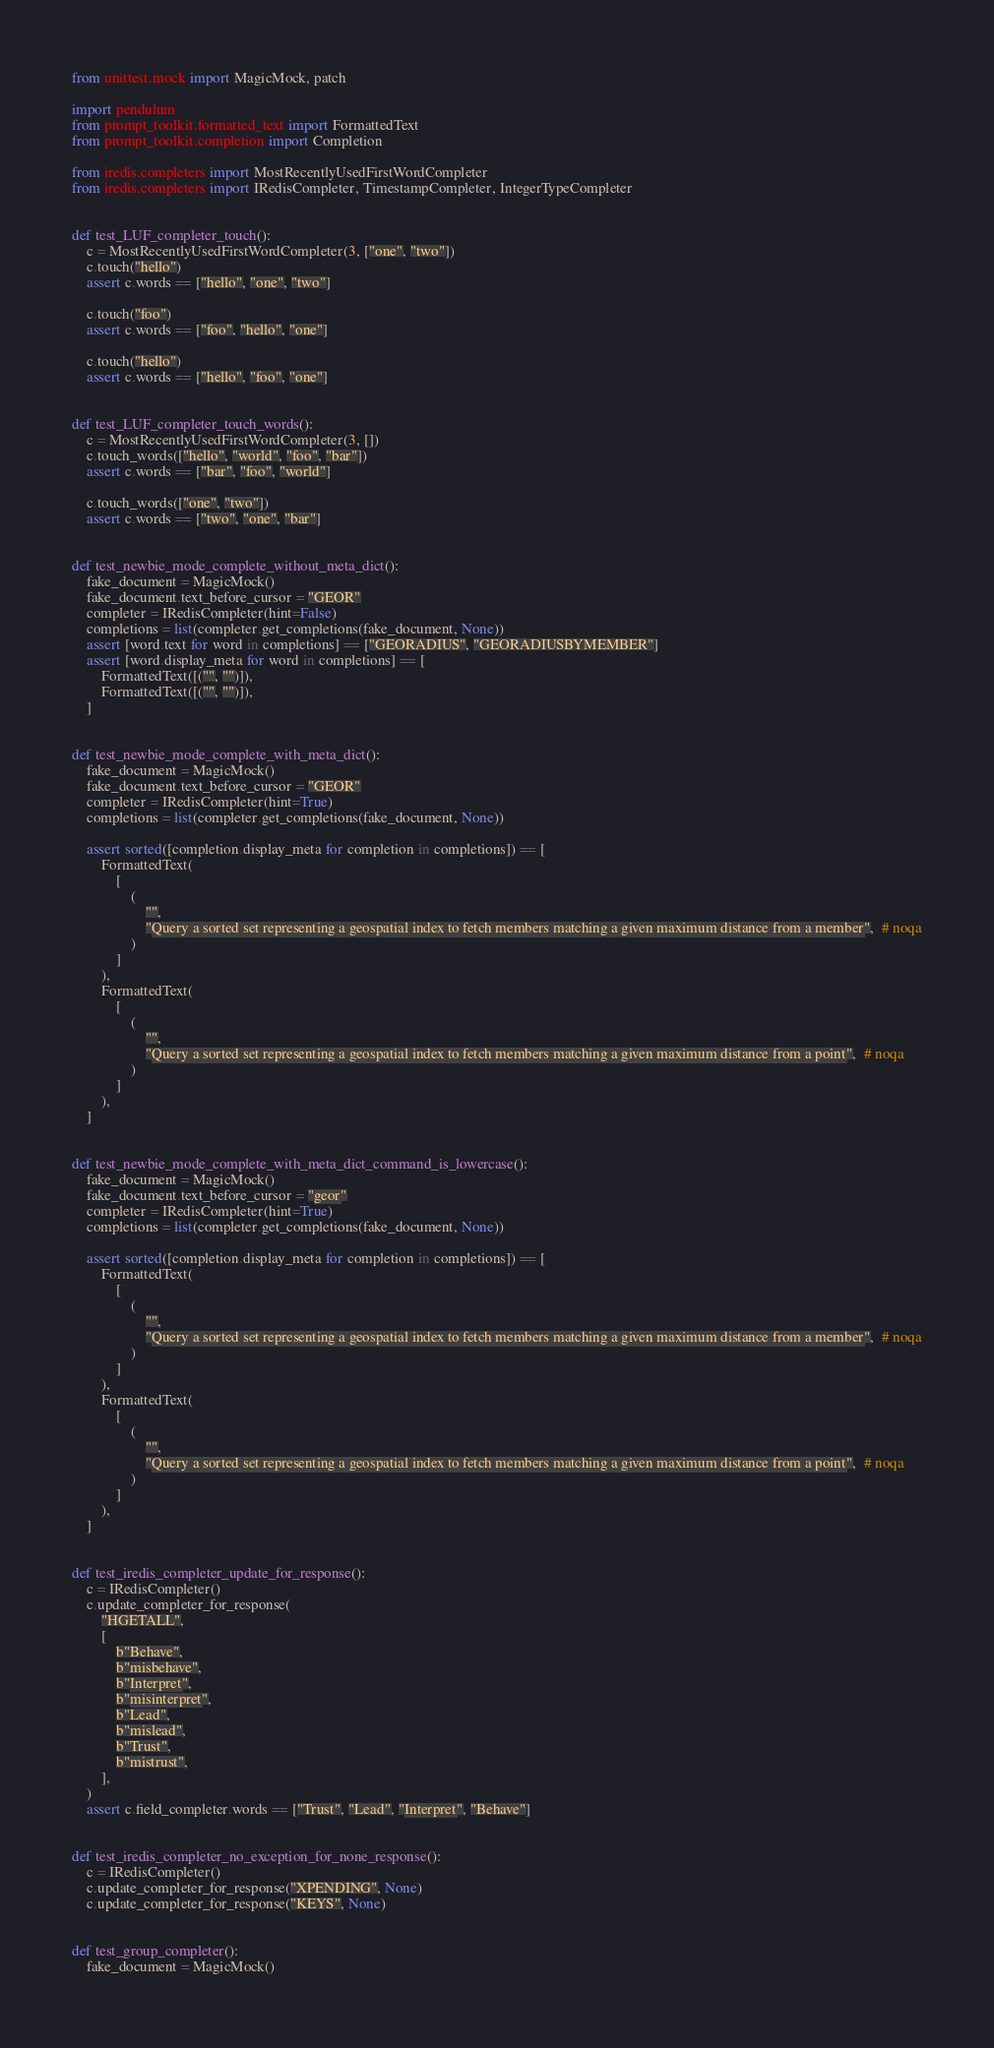<code> <loc_0><loc_0><loc_500><loc_500><_Python_>from unittest.mock import MagicMock, patch

import pendulum
from prompt_toolkit.formatted_text import FormattedText
from prompt_toolkit.completion import Completion

from iredis.completers import MostRecentlyUsedFirstWordCompleter
from iredis.completers import IRedisCompleter, TimestampCompleter, IntegerTypeCompleter


def test_LUF_completer_touch():
    c = MostRecentlyUsedFirstWordCompleter(3, ["one", "two"])
    c.touch("hello")
    assert c.words == ["hello", "one", "two"]

    c.touch("foo")
    assert c.words == ["foo", "hello", "one"]

    c.touch("hello")
    assert c.words == ["hello", "foo", "one"]


def test_LUF_completer_touch_words():
    c = MostRecentlyUsedFirstWordCompleter(3, [])
    c.touch_words(["hello", "world", "foo", "bar"])
    assert c.words == ["bar", "foo", "world"]

    c.touch_words(["one", "two"])
    assert c.words == ["two", "one", "bar"]


def test_newbie_mode_complete_without_meta_dict():
    fake_document = MagicMock()
    fake_document.text_before_cursor = "GEOR"
    completer = IRedisCompleter(hint=False)
    completions = list(completer.get_completions(fake_document, None))
    assert [word.text for word in completions] == ["GEORADIUS", "GEORADIUSBYMEMBER"]
    assert [word.display_meta for word in completions] == [
        FormattedText([("", "")]),
        FormattedText([("", "")]),
    ]


def test_newbie_mode_complete_with_meta_dict():
    fake_document = MagicMock()
    fake_document.text_before_cursor = "GEOR"
    completer = IRedisCompleter(hint=True)
    completions = list(completer.get_completions(fake_document, None))

    assert sorted([completion.display_meta for completion in completions]) == [
        FormattedText(
            [
                (
                    "",
                    "Query a sorted set representing a geospatial index to fetch members matching a given maximum distance from a member",  # noqa
                )
            ]
        ),
        FormattedText(
            [
                (
                    "",
                    "Query a sorted set representing a geospatial index to fetch members matching a given maximum distance from a point",  # noqa
                )
            ]
        ),
    ]


def test_newbie_mode_complete_with_meta_dict_command_is_lowercase():
    fake_document = MagicMock()
    fake_document.text_before_cursor = "geor"
    completer = IRedisCompleter(hint=True)
    completions = list(completer.get_completions(fake_document, None))

    assert sorted([completion.display_meta for completion in completions]) == [
        FormattedText(
            [
                (
                    "",
                    "Query a sorted set representing a geospatial index to fetch members matching a given maximum distance from a member",  # noqa
                )
            ]
        ),
        FormattedText(
            [
                (
                    "",
                    "Query a sorted set representing a geospatial index to fetch members matching a given maximum distance from a point",  # noqa
                )
            ]
        ),
    ]


def test_iredis_completer_update_for_response():
    c = IRedisCompleter()
    c.update_completer_for_response(
        "HGETALL",
        [
            b"Behave",
            b"misbehave",
            b"Interpret",
            b"misinterpret",
            b"Lead",
            b"mislead",
            b"Trust",
            b"mistrust",
        ],
    )
    assert c.field_completer.words == ["Trust", "Lead", "Interpret", "Behave"]


def test_iredis_completer_no_exception_for_none_response():
    c = IRedisCompleter()
    c.update_completer_for_response("XPENDING", None)
    c.update_completer_for_response("KEYS", None)


def test_group_completer():
    fake_document = MagicMock()</code> 